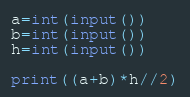<code> <loc_0><loc_0><loc_500><loc_500><_Python_>a=int(input())
b=int(input())
h=int(input())

print((a+b)*h//2)</code> 